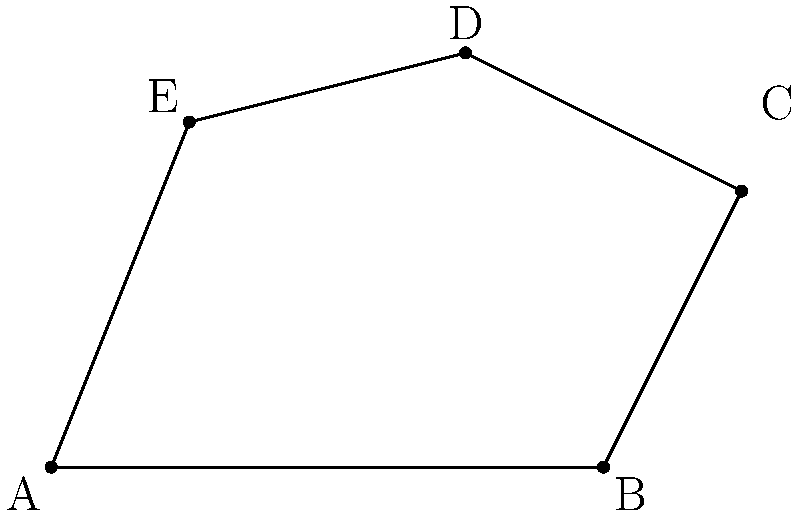As a hotel reservation specialist, you're tasked with calculating the area of an irregularly shaped ballroom for a wedding reception. The ballroom's floor plan can be represented on a coordinate plane with the following vertices: A(0,0), B(8,0), C(10,4), D(6,6), and E(2,5). Calculate the area of this ballroom using coordinate geometry. To find the area of this irregular polygon, we can use the Shoelace formula (also known as the surveyor's formula). The steps are as follows:

1) First, list the coordinates in order (either clockwise or counterclockwise), repeating the first coordinate at the end:
   (0,0), (8,0), (10,4), (6,6), (2,5), (0,0)

2) Multiply each x-coordinate by the y-coordinate of the next point:
   $0 \cdot 0 + 8 \cdot 4 + 10 \cdot 6 + 6 \cdot 5 + 2 \cdot 0 = 32 + 60 + 30 = 122$

3) Multiply each y-coordinate by the x-coordinate of the next point:
   $0 \cdot 8 + 0 \cdot 10 + 4 \cdot 6 + 6 \cdot 2 + 5 \cdot 0 = 24 + 12 = 36$

4) Subtract the result of step 3 from the result of step 2:
   $122 - 36 = 86$

5) Divide the result by 2 to get the final area:
   $\frac{86}{2} = 43$

Therefore, the area of the ballroom is 43 square units.
Answer: 43 square units 